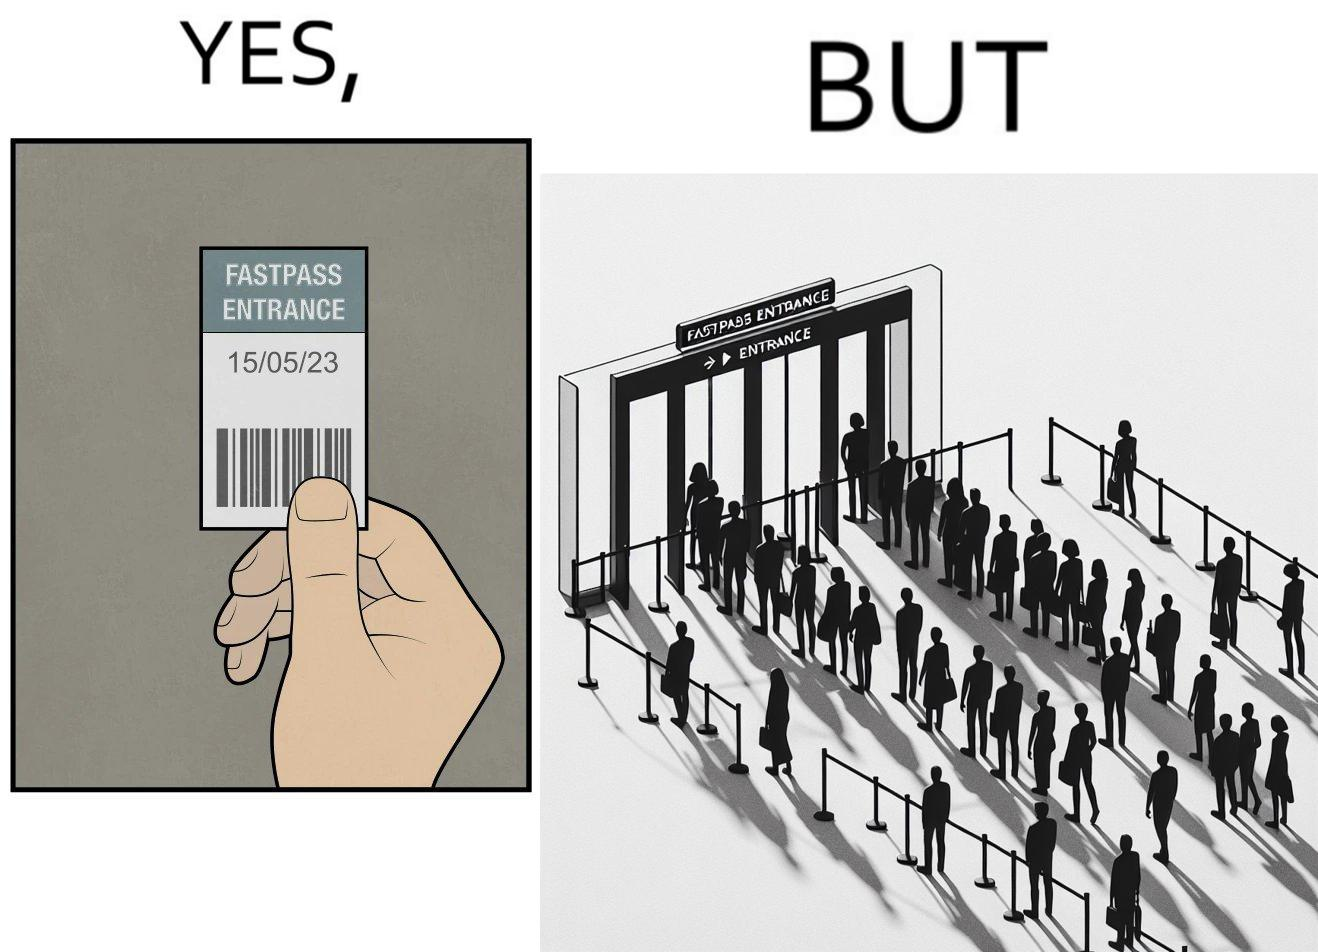Describe the contrast between the left and right parts of this image. In the left part of the image: a person holding a "FASTPASS ENTRANCE" ticket or token of date "15/05/23" with some barcode In the right part of the image: people in a long queue in front of "FASTPASS ENTRANCE"  gate and "ENTRANCE" gate is vacant without any queue 